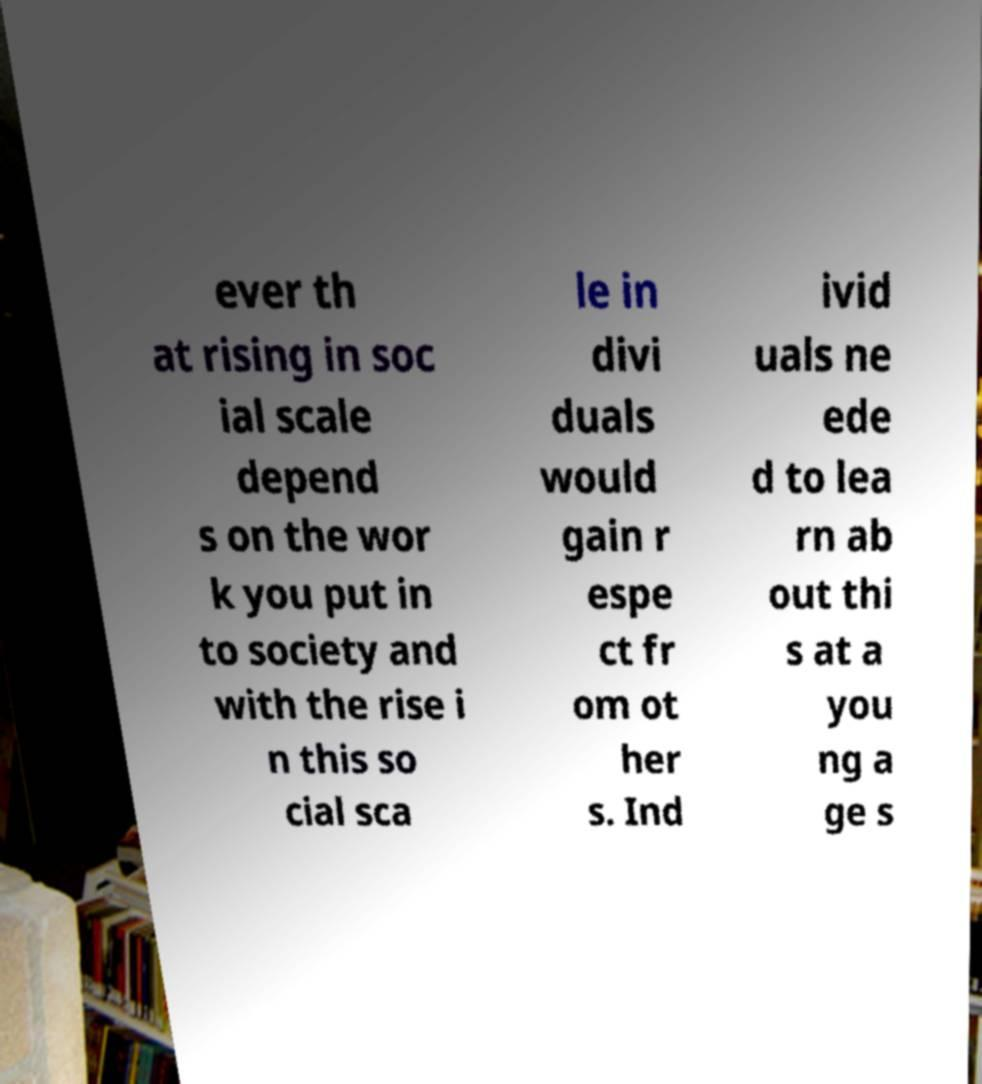Could you assist in decoding the text presented in this image and type it out clearly? ever th at rising in soc ial scale depend s on the wor k you put in to society and with the rise i n this so cial sca le in divi duals would gain r espe ct fr om ot her s. Ind ivid uals ne ede d to lea rn ab out thi s at a you ng a ge s 